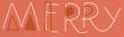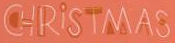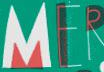What words can you see in these images in sequence, separated by a semicolon? MERRY; CHRİSTMAS; MER 